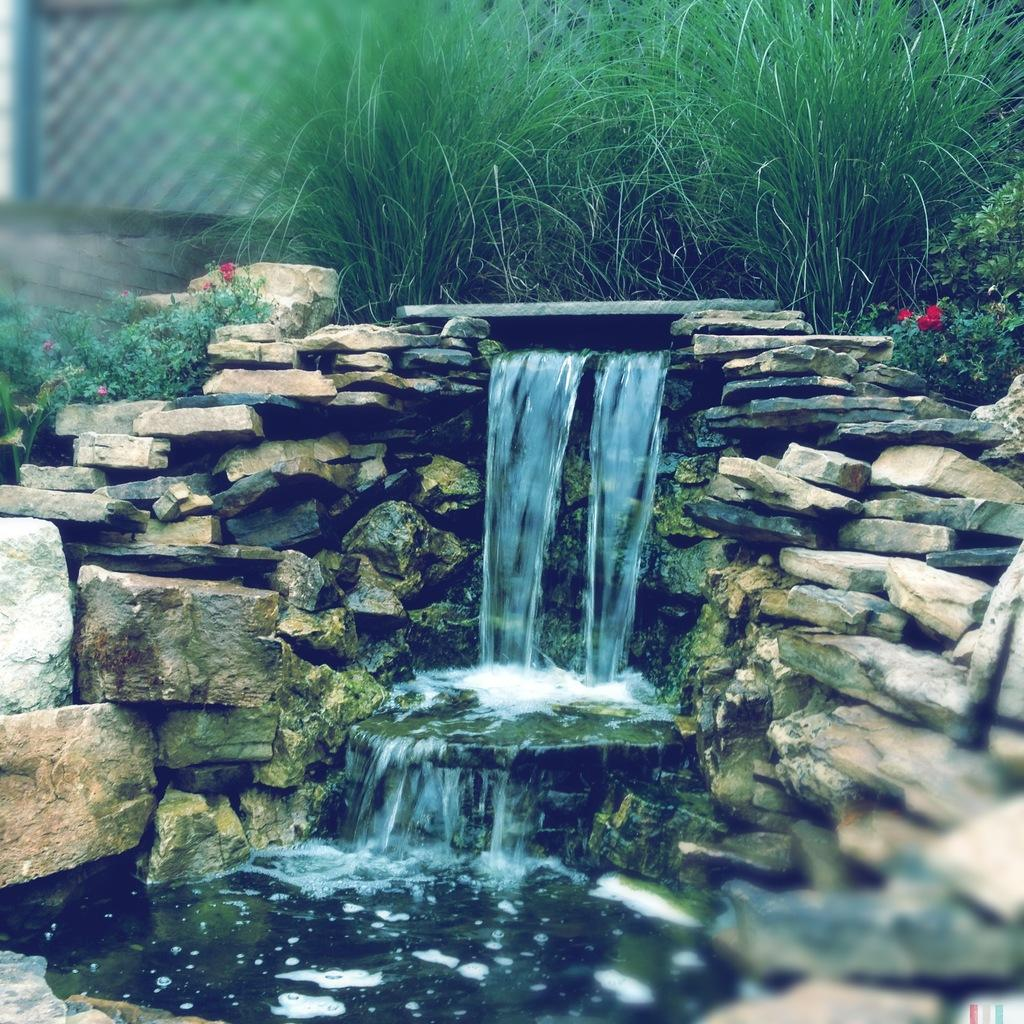What is the main feature in the center of the image? There is water in the center of the image. What can be seen on the right side of the image? There are rocks on the right side of the image. What is present on the left side of the image? There are rocks on the left side of the image. What type of vegetation is visible at the top side of the image? There are plants at the top side of the image. What type of trade is happening between the rocks in the image? There is no trade happening between the rocks in the image, as rocks are inanimate objects and cannot engage in trade. 